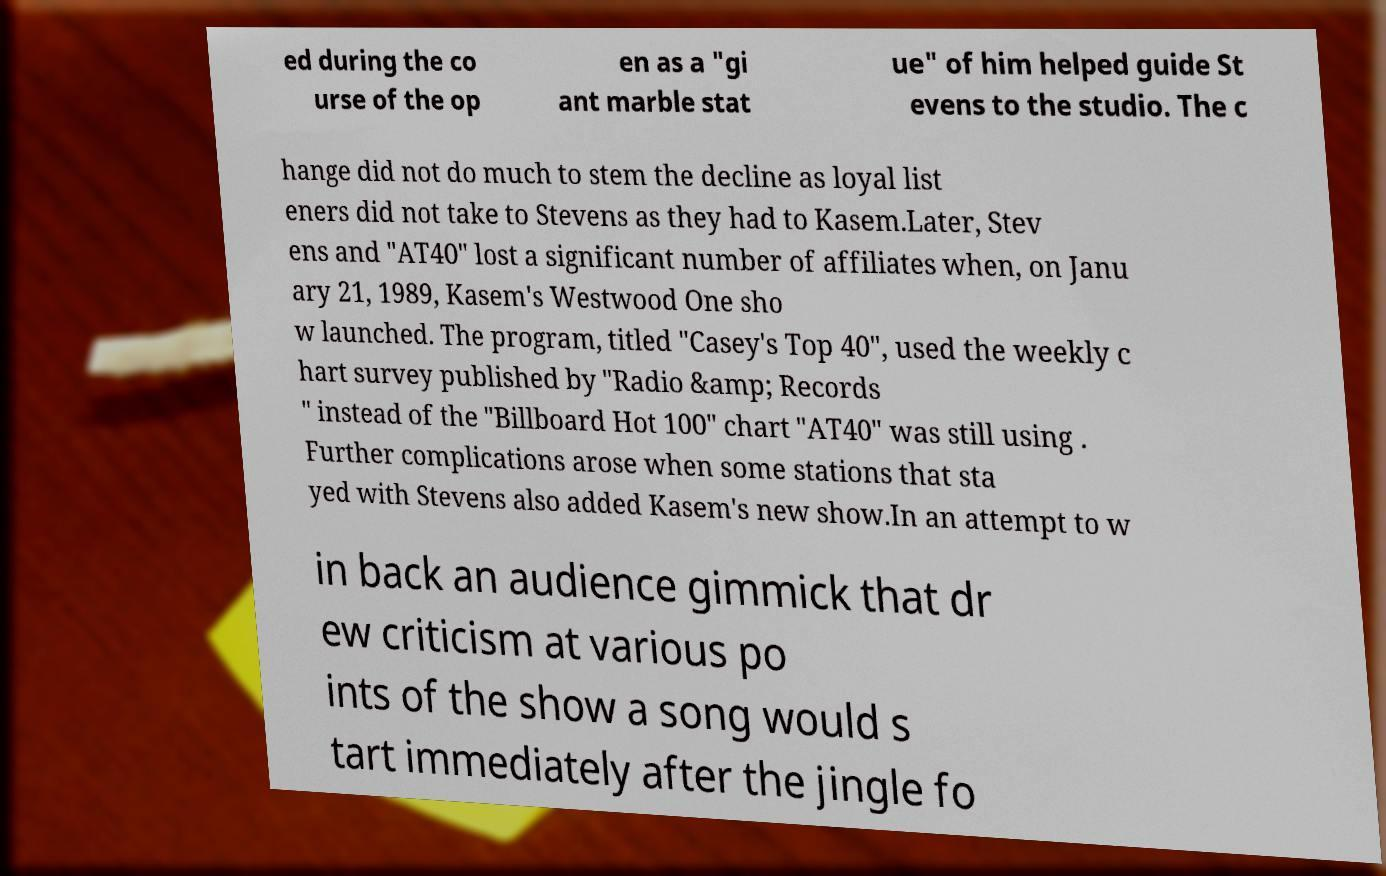Can you accurately transcribe the text from the provided image for me? ed during the co urse of the op en as a "gi ant marble stat ue" of him helped guide St evens to the studio. The c hange did not do much to stem the decline as loyal list eners did not take to Stevens as they had to Kasem.Later, Stev ens and "AT40" lost a significant number of affiliates when, on Janu ary 21, 1989, Kasem's Westwood One sho w launched. The program, titled "Casey's Top 40", used the weekly c hart survey published by "Radio &amp; Records " instead of the "Billboard Hot 100" chart "AT40" was still using . Further complications arose when some stations that sta yed with Stevens also added Kasem's new show.In an attempt to w in back an audience gimmick that dr ew criticism at various po ints of the show a song would s tart immediately after the jingle fo 